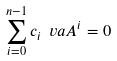<formula> <loc_0><loc_0><loc_500><loc_500>\sum _ { i = 0 } ^ { n - 1 } c _ { i } \ v a A ^ { i } = 0</formula> 